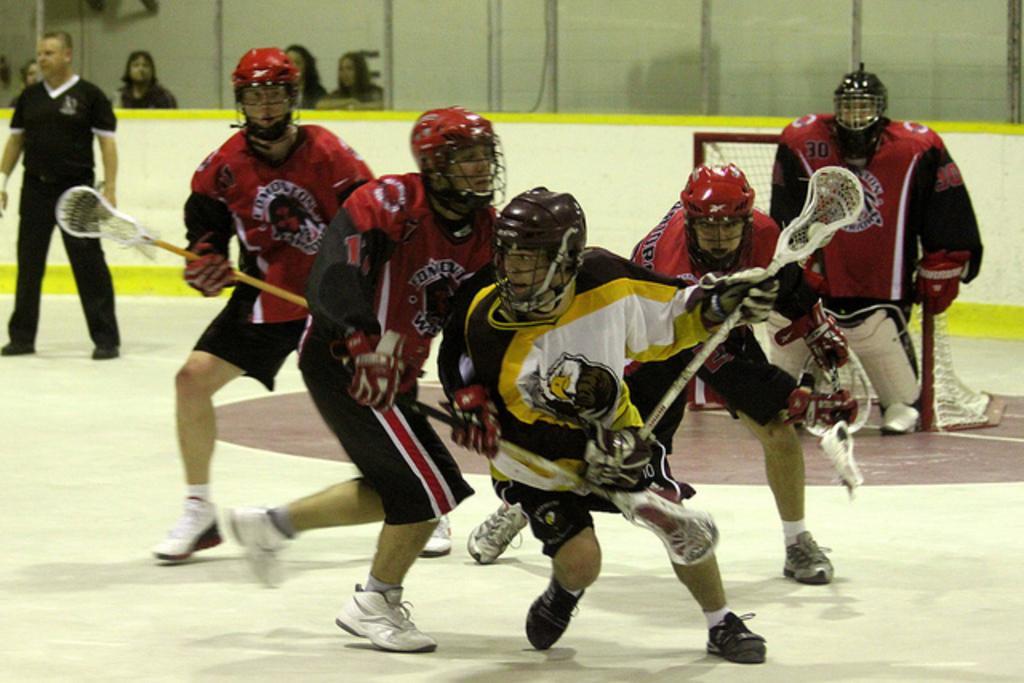Please provide a concise description of this image. In this picture we can see five persons are playing field lacrosse sport, they are wearing helmets, gloves and shoes, we can see some people in the background, these five persons are holding sticks. 